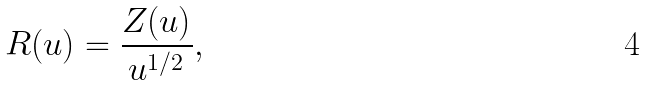<formula> <loc_0><loc_0><loc_500><loc_500>R ( u ) = \frac { Z ( u ) } { u ^ { 1 / 2 } } ,</formula> 